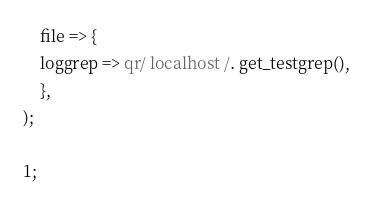<code> <loc_0><loc_0><loc_500><loc_500><_Perl_>    file => {
	loggrep => qr/ localhost /. get_testgrep(),
    },
);

1;
</code> 